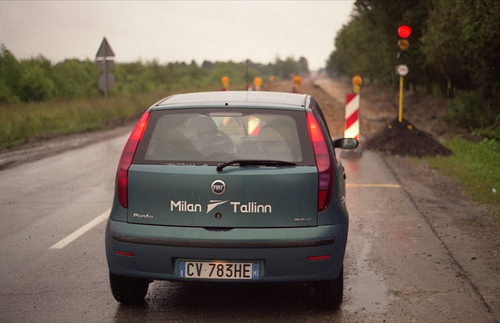Please transcribe the text in this image. 783HE CV Milan Tallinn 